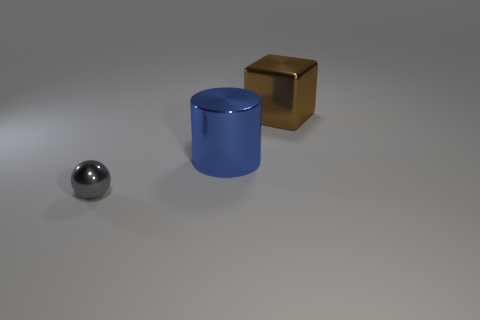Add 2 large blue cylinders. How many objects exist? 5 Subtract all spheres. How many objects are left? 2 Subtract all blue balls. How many purple cylinders are left? 0 Subtract all blue cylinders. Subtract all small things. How many objects are left? 1 Add 1 brown blocks. How many brown blocks are left? 2 Add 3 tiny green balls. How many tiny green balls exist? 3 Subtract 0 green spheres. How many objects are left? 3 Subtract all red spheres. Subtract all red blocks. How many spheres are left? 1 